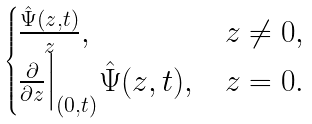<formula> <loc_0><loc_0><loc_500><loc_500>\begin{cases} \frac { \hat { \Psi } ( z , t ) } { z } , & z \neq 0 , \\ \frac { \partial } { \partial z } \Big | _ { ( 0 , t ) } \hat { \Psi } ( z , t ) , & z = 0 . \end{cases}</formula> 